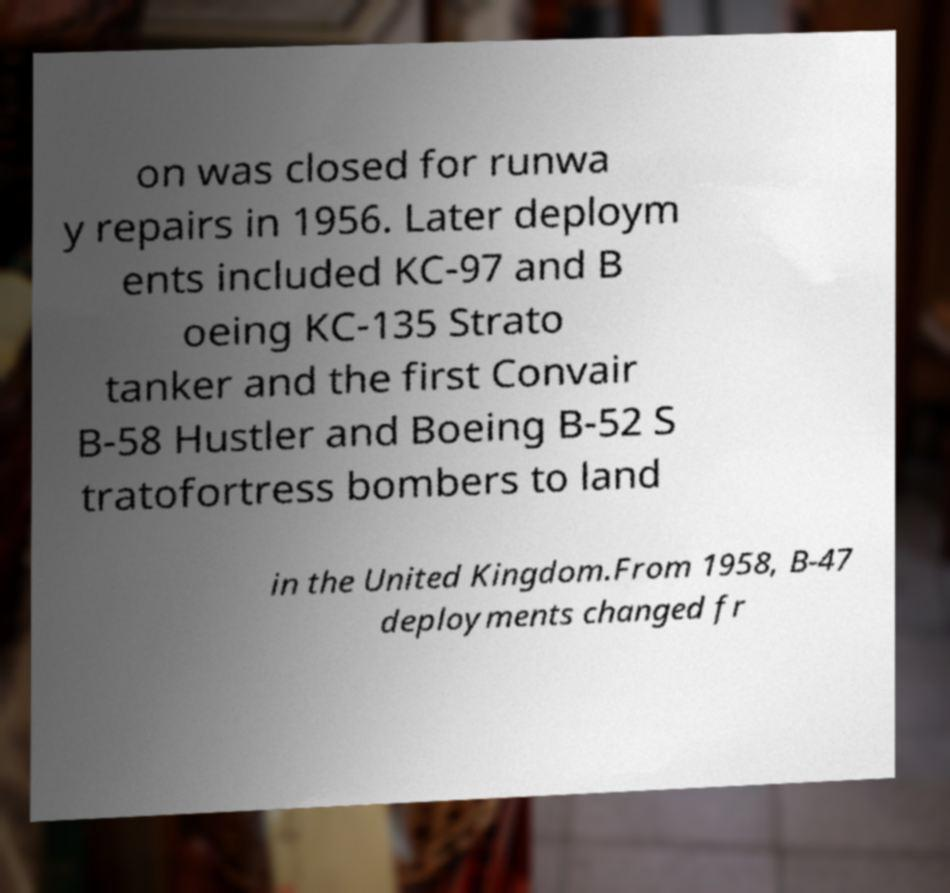I need the written content from this picture converted into text. Can you do that? on was closed for runwa y repairs in 1956. Later deploym ents included KC-97 and B oeing KC-135 Strato tanker and the first Convair B-58 Hustler and Boeing B-52 S tratofortress bombers to land in the United Kingdom.From 1958, B-47 deployments changed fr 